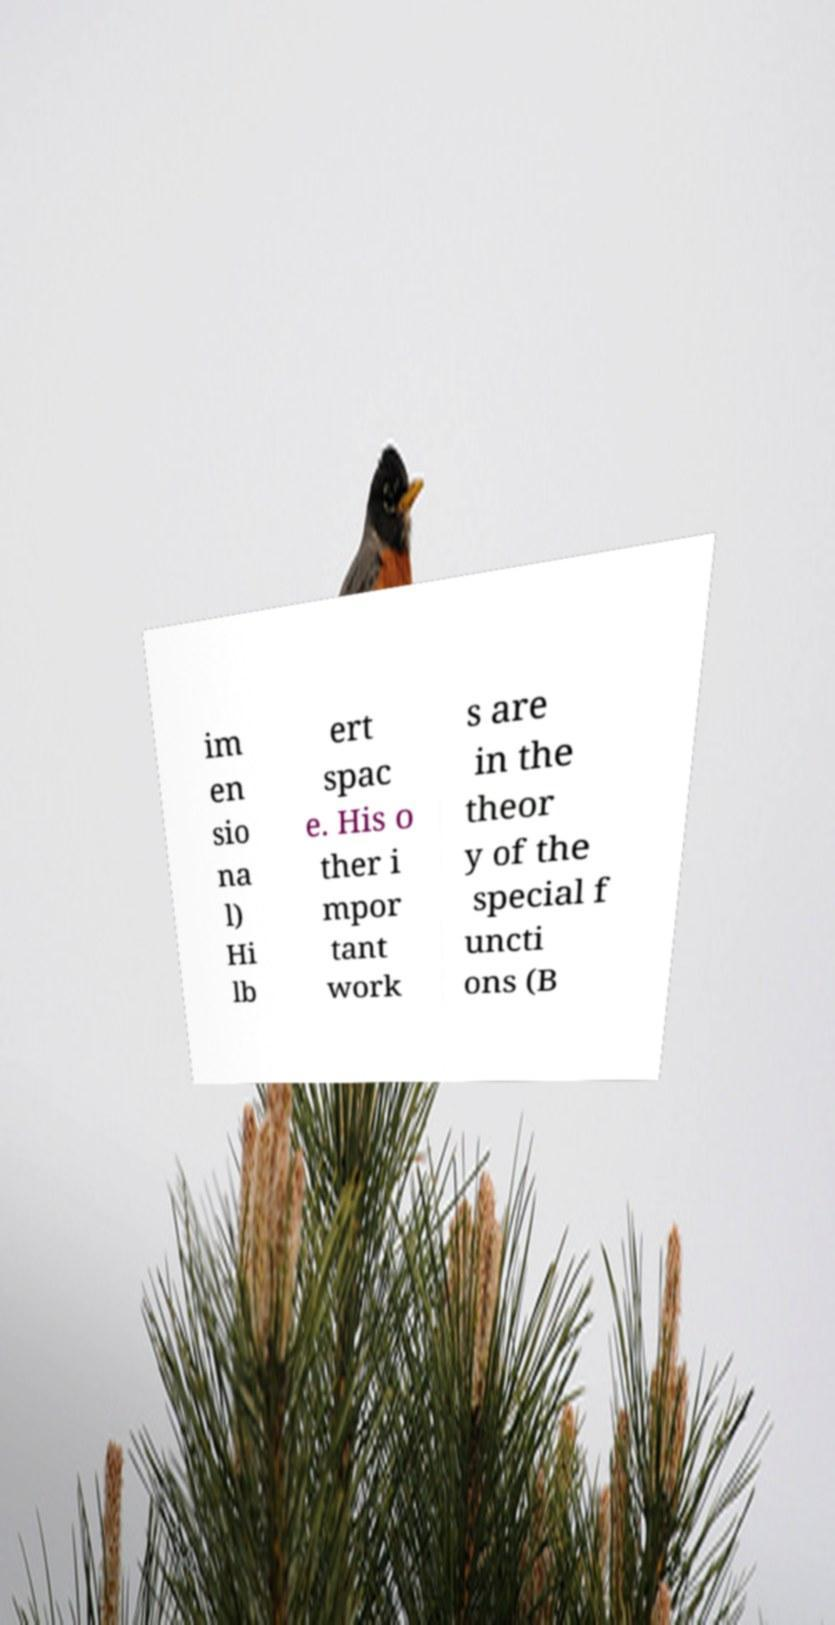Please read and relay the text visible in this image. What does it say? im en sio na l) Hi lb ert spac e. His o ther i mpor tant work s are in the theor y of the special f uncti ons (B 